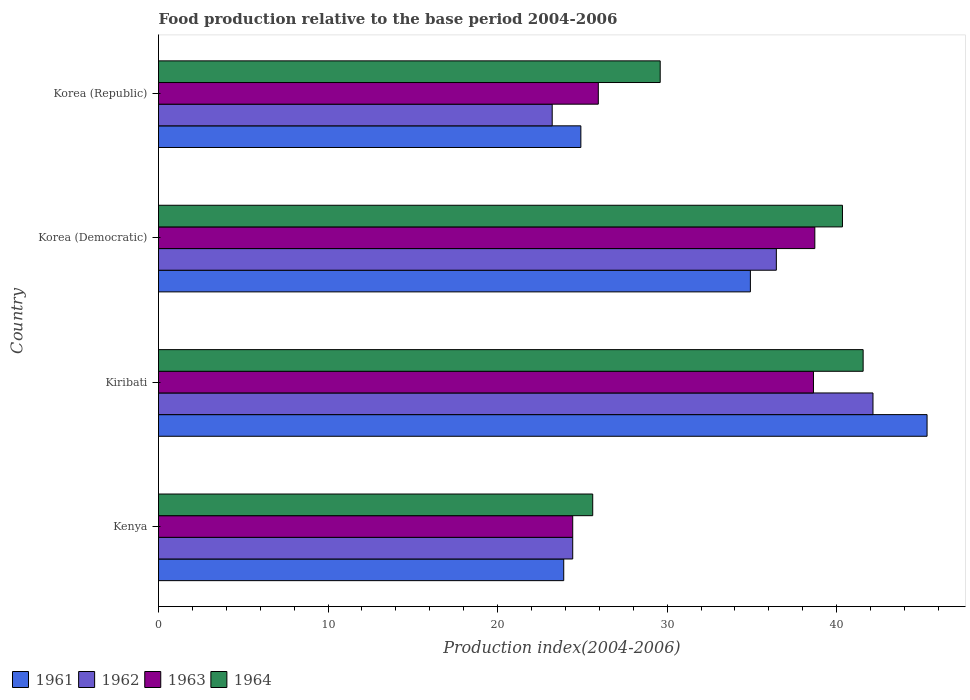How many groups of bars are there?
Make the answer very short. 4. How many bars are there on the 1st tick from the bottom?
Offer a terse response. 4. What is the label of the 4th group of bars from the top?
Provide a succinct answer. Kenya. What is the food production index in 1964 in Kiribati?
Provide a succinct answer. 41.56. Across all countries, what is the maximum food production index in 1962?
Make the answer very short. 42.14. Across all countries, what is the minimum food production index in 1964?
Make the answer very short. 25.61. In which country was the food production index in 1962 maximum?
Give a very brief answer. Kiribati. What is the total food production index in 1963 in the graph?
Give a very brief answer. 127.71. What is the difference between the food production index in 1963 in Kenya and that in Korea (Republic)?
Your answer should be compact. -1.51. What is the difference between the food production index in 1962 in Kenya and the food production index in 1963 in Kiribati?
Give a very brief answer. -14.2. What is the average food production index in 1964 per country?
Make the answer very short. 34.27. What is the difference between the food production index in 1961 and food production index in 1964 in Korea (Democratic)?
Offer a very short reply. -5.43. What is the ratio of the food production index in 1962 in Kiribati to that in Korea (Democratic)?
Ensure brevity in your answer.  1.16. Is the food production index in 1961 in Korea (Democratic) less than that in Korea (Republic)?
Offer a very short reply. No. Is the difference between the food production index in 1961 in Kenya and Korea (Republic) greater than the difference between the food production index in 1964 in Kenya and Korea (Republic)?
Make the answer very short. Yes. What is the difference between the highest and the second highest food production index in 1961?
Your response must be concise. 10.42. What is the difference between the highest and the lowest food production index in 1961?
Your answer should be compact. 21.43. Is the sum of the food production index in 1963 in Kiribati and Korea (Republic) greater than the maximum food production index in 1962 across all countries?
Make the answer very short. Yes. What does the 3rd bar from the bottom in Korea (Democratic) represents?
Provide a short and direct response. 1963. Is it the case that in every country, the sum of the food production index in 1963 and food production index in 1961 is greater than the food production index in 1964?
Your response must be concise. Yes. How many bars are there?
Make the answer very short. 16. How many countries are there in the graph?
Your answer should be compact. 4. What is the difference between two consecutive major ticks on the X-axis?
Your answer should be compact. 10. Are the values on the major ticks of X-axis written in scientific E-notation?
Your answer should be compact. No. Does the graph contain any zero values?
Offer a terse response. No. How many legend labels are there?
Your answer should be compact. 4. What is the title of the graph?
Ensure brevity in your answer.  Food production relative to the base period 2004-2006. What is the label or title of the X-axis?
Give a very brief answer. Production index(2004-2006). What is the label or title of the Y-axis?
Make the answer very short. Country. What is the Production index(2004-2006) in 1961 in Kenya?
Provide a short and direct response. 23.9. What is the Production index(2004-2006) in 1962 in Kenya?
Keep it short and to the point. 24.43. What is the Production index(2004-2006) in 1963 in Kenya?
Keep it short and to the point. 24.43. What is the Production index(2004-2006) in 1964 in Kenya?
Your response must be concise. 25.61. What is the Production index(2004-2006) of 1961 in Kiribati?
Make the answer very short. 45.33. What is the Production index(2004-2006) in 1962 in Kiribati?
Keep it short and to the point. 42.14. What is the Production index(2004-2006) in 1963 in Kiribati?
Your response must be concise. 38.63. What is the Production index(2004-2006) in 1964 in Kiribati?
Provide a short and direct response. 41.56. What is the Production index(2004-2006) in 1961 in Korea (Democratic)?
Ensure brevity in your answer.  34.91. What is the Production index(2004-2006) of 1962 in Korea (Democratic)?
Make the answer very short. 36.44. What is the Production index(2004-2006) in 1963 in Korea (Democratic)?
Keep it short and to the point. 38.71. What is the Production index(2004-2006) in 1964 in Korea (Democratic)?
Ensure brevity in your answer.  40.34. What is the Production index(2004-2006) of 1961 in Korea (Republic)?
Offer a terse response. 24.91. What is the Production index(2004-2006) in 1962 in Korea (Republic)?
Keep it short and to the point. 23.22. What is the Production index(2004-2006) of 1963 in Korea (Republic)?
Offer a very short reply. 25.94. What is the Production index(2004-2006) in 1964 in Korea (Republic)?
Ensure brevity in your answer.  29.59. Across all countries, what is the maximum Production index(2004-2006) of 1961?
Give a very brief answer. 45.33. Across all countries, what is the maximum Production index(2004-2006) of 1962?
Your response must be concise. 42.14. Across all countries, what is the maximum Production index(2004-2006) in 1963?
Ensure brevity in your answer.  38.71. Across all countries, what is the maximum Production index(2004-2006) of 1964?
Provide a succinct answer. 41.56. Across all countries, what is the minimum Production index(2004-2006) of 1961?
Offer a very short reply. 23.9. Across all countries, what is the minimum Production index(2004-2006) in 1962?
Make the answer very short. 23.22. Across all countries, what is the minimum Production index(2004-2006) of 1963?
Your answer should be compact. 24.43. Across all countries, what is the minimum Production index(2004-2006) in 1964?
Ensure brevity in your answer.  25.61. What is the total Production index(2004-2006) in 1961 in the graph?
Offer a terse response. 129.05. What is the total Production index(2004-2006) in 1962 in the graph?
Your answer should be compact. 126.23. What is the total Production index(2004-2006) of 1963 in the graph?
Provide a succinct answer. 127.71. What is the total Production index(2004-2006) of 1964 in the graph?
Make the answer very short. 137.1. What is the difference between the Production index(2004-2006) of 1961 in Kenya and that in Kiribati?
Offer a terse response. -21.43. What is the difference between the Production index(2004-2006) of 1962 in Kenya and that in Kiribati?
Offer a very short reply. -17.71. What is the difference between the Production index(2004-2006) of 1963 in Kenya and that in Kiribati?
Your answer should be compact. -14.2. What is the difference between the Production index(2004-2006) in 1964 in Kenya and that in Kiribati?
Provide a short and direct response. -15.95. What is the difference between the Production index(2004-2006) in 1961 in Kenya and that in Korea (Democratic)?
Provide a succinct answer. -11.01. What is the difference between the Production index(2004-2006) of 1962 in Kenya and that in Korea (Democratic)?
Your answer should be compact. -12.01. What is the difference between the Production index(2004-2006) in 1963 in Kenya and that in Korea (Democratic)?
Your answer should be compact. -14.28. What is the difference between the Production index(2004-2006) of 1964 in Kenya and that in Korea (Democratic)?
Make the answer very short. -14.73. What is the difference between the Production index(2004-2006) of 1961 in Kenya and that in Korea (Republic)?
Provide a succinct answer. -1.01. What is the difference between the Production index(2004-2006) of 1962 in Kenya and that in Korea (Republic)?
Offer a very short reply. 1.21. What is the difference between the Production index(2004-2006) of 1963 in Kenya and that in Korea (Republic)?
Provide a succinct answer. -1.51. What is the difference between the Production index(2004-2006) of 1964 in Kenya and that in Korea (Republic)?
Your answer should be compact. -3.98. What is the difference between the Production index(2004-2006) in 1961 in Kiribati and that in Korea (Democratic)?
Give a very brief answer. 10.42. What is the difference between the Production index(2004-2006) of 1963 in Kiribati and that in Korea (Democratic)?
Offer a very short reply. -0.08. What is the difference between the Production index(2004-2006) of 1964 in Kiribati and that in Korea (Democratic)?
Your response must be concise. 1.22. What is the difference between the Production index(2004-2006) of 1961 in Kiribati and that in Korea (Republic)?
Offer a terse response. 20.42. What is the difference between the Production index(2004-2006) in 1962 in Kiribati and that in Korea (Republic)?
Give a very brief answer. 18.92. What is the difference between the Production index(2004-2006) of 1963 in Kiribati and that in Korea (Republic)?
Ensure brevity in your answer.  12.69. What is the difference between the Production index(2004-2006) in 1964 in Kiribati and that in Korea (Republic)?
Provide a short and direct response. 11.97. What is the difference between the Production index(2004-2006) in 1961 in Korea (Democratic) and that in Korea (Republic)?
Your response must be concise. 10. What is the difference between the Production index(2004-2006) in 1962 in Korea (Democratic) and that in Korea (Republic)?
Provide a short and direct response. 13.22. What is the difference between the Production index(2004-2006) in 1963 in Korea (Democratic) and that in Korea (Republic)?
Provide a short and direct response. 12.77. What is the difference between the Production index(2004-2006) in 1964 in Korea (Democratic) and that in Korea (Republic)?
Provide a succinct answer. 10.75. What is the difference between the Production index(2004-2006) in 1961 in Kenya and the Production index(2004-2006) in 1962 in Kiribati?
Provide a succinct answer. -18.24. What is the difference between the Production index(2004-2006) of 1961 in Kenya and the Production index(2004-2006) of 1963 in Kiribati?
Provide a succinct answer. -14.73. What is the difference between the Production index(2004-2006) of 1961 in Kenya and the Production index(2004-2006) of 1964 in Kiribati?
Provide a short and direct response. -17.66. What is the difference between the Production index(2004-2006) in 1962 in Kenya and the Production index(2004-2006) in 1963 in Kiribati?
Your response must be concise. -14.2. What is the difference between the Production index(2004-2006) in 1962 in Kenya and the Production index(2004-2006) in 1964 in Kiribati?
Give a very brief answer. -17.13. What is the difference between the Production index(2004-2006) of 1963 in Kenya and the Production index(2004-2006) of 1964 in Kiribati?
Your answer should be compact. -17.13. What is the difference between the Production index(2004-2006) in 1961 in Kenya and the Production index(2004-2006) in 1962 in Korea (Democratic)?
Offer a very short reply. -12.54. What is the difference between the Production index(2004-2006) of 1961 in Kenya and the Production index(2004-2006) of 1963 in Korea (Democratic)?
Offer a terse response. -14.81. What is the difference between the Production index(2004-2006) of 1961 in Kenya and the Production index(2004-2006) of 1964 in Korea (Democratic)?
Your response must be concise. -16.44. What is the difference between the Production index(2004-2006) in 1962 in Kenya and the Production index(2004-2006) in 1963 in Korea (Democratic)?
Provide a succinct answer. -14.28. What is the difference between the Production index(2004-2006) in 1962 in Kenya and the Production index(2004-2006) in 1964 in Korea (Democratic)?
Keep it short and to the point. -15.91. What is the difference between the Production index(2004-2006) in 1963 in Kenya and the Production index(2004-2006) in 1964 in Korea (Democratic)?
Your response must be concise. -15.91. What is the difference between the Production index(2004-2006) of 1961 in Kenya and the Production index(2004-2006) of 1962 in Korea (Republic)?
Ensure brevity in your answer.  0.68. What is the difference between the Production index(2004-2006) in 1961 in Kenya and the Production index(2004-2006) in 1963 in Korea (Republic)?
Make the answer very short. -2.04. What is the difference between the Production index(2004-2006) in 1961 in Kenya and the Production index(2004-2006) in 1964 in Korea (Republic)?
Offer a terse response. -5.69. What is the difference between the Production index(2004-2006) in 1962 in Kenya and the Production index(2004-2006) in 1963 in Korea (Republic)?
Your answer should be very brief. -1.51. What is the difference between the Production index(2004-2006) of 1962 in Kenya and the Production index(2004-2006) of 1964 in Korea (Republic)?
Offer a terse response. -5.16. What is the difference between the Production index(2004-2006) of 1963 in Kenya and the Production index(2004-2006) of 1964 in Korea (Republic)?
Offer a very short reply. -5.16. What is the difference between the Production index(2004-2006) in 1961 in Kiribati and the Production index(2004-2006) in 1962 in Korea (Democratic)?
Make the answer very short. 8.89. What is the difference between the Production index(2004-2006) in 1961 in Kiribati and the Production index(2004-2006) in 1963 in Korea (Democratic)?
Provide a succinct answer. 6.62. What is the difference between the Production index(2004-2006) of 1961 in Kiribati and the Production index(2004-2006) of 1964 in Korea (Democratic)?
Provide a succinct answer. 4.99. What is the difference between the Production index(2004-2006) of 1962 in Kiribati and the Production index(2004-2006) of 1963 in Korea (Democratic)?
Give a very brief answer. 3.43. What is the difference between the Production index(2004-2006) of 1963 in Kiribati and the Production index(2004-2006) of 1964 in Korea (Democratic)?
Your answer should be very brief. -1.71. What is the difference between the Production index(2004-2006) in 1961 in Kiribati and the Production index(2004-2006) in 1962 in Korea (Republic)?
Offer a very short reply. 22.11. What is the difference between the Production index(2004-2006) in 1961 in Kiribati and the Production index(2004-2006) in 1963 in Korea (Republic)?
Provide a short and direct response. 19.39. What is the difference between the Production index(2004-2006) in 1961 in Kiribati and the Production index(2004-2006) in 1964 in Korea (Republic)?
Keep it short and to the point. 15.74. What is the difference between the Production index(2004-2006) in 1962 in Kiribati and the Production index(2004-2006) in 1963 in Korea (Republic)?
Offer a terse response. 16.2. What is the difference between the Production index(2004-2006) in 1962 in Kiribati and the Production index(2004-2006) in 1964 in Korea (Republic)?
Provide a succinct answer. 12.55. What is the difference between the Production index(2004-2006) of 1963 in Kiribati and the Production index(2004-2006) of 1964 in Korea (Republic)?
Offer a very short reply. 9.04. What is the difference between the Production index(2004-2006) of 1961 in Korea (Democratic) and the Production index(2004-2006) of 1962 in Korea (Republic)?
Give a very brief answer. 11.69. What is the difference between the Production index(2004-2006) in 1961 in Korea (Democratic) and the Production index(2004-2006) in 1963 in Korea (Republic)?
Offer a very short reply. 8.97. What is the difference between the Production index(2004-2006) in 1961 in Korea (Democratic) and the Production index(2004-2006) in 1964 in Korea (Republic)?
Your answer should be compact. 5.32. What is the difference between the Production index(2004-2006) of 1962 in Korea (Democratic) and the Production index(2004-2006) of 1963 in Korea (Republic)?
Offer a very short reply. 10.5. What is the difference between the Production index(2004-2006) in 1962 in Korea (Democratic) and the Production index(2004-2006) in 1964 in Korea (Republic)?
Provide a succinct answer. 6.85. What is the difference between the Production index(2004-2006) of 1963 in Korea (Democratic) and the Production index(2004-2006) of 1964 in Korea (Republic)?
Ensure brevity in your answer.  9.12. What is the average Production index(2004-2006) in 1961 per country?
Give a very brief answer. 32.26. What is the average Production index(2004-2006) in 1962 per country?
Your answer should be compact. 31.56. What is the average Production index(2004-2006) of 1963 per country?
Your answer should be very brief. 31.93. What is the average Production index(2004-2006) in 1964 per country?
Give a very brief answer. 34.27. What is the difference between the Production index(2004-2006) in 1961 and Production index(2004-2006) in 1962 in Kenya?
Provide a short and direct response. -0.53. What is the difference between the Production index(2004-2006) in 1961 and Production index(2004-2006) in 1963 in Kenya?
Your response must be concise. -0.53. What is the difference between the Production index(2004-2006) in 1961 and Production index(2004-2006) in 1964 in Kenya?
Make the answer very short. -1.71. What is the difference between the Production index(2004-2006) of 1962 and Production index(2004-2006) of 1964 in Kenya?
Your response must be concise. -1.18. What is the difference between the Production index(2004-2006) in 1963 and Production index(2004-2006) in 1964 in Kenya?
Your response must be concise. -1.18. What is the difference between the Production index(2004-2006) in 1961 and Production index(2004-2006) in 1962 in Kiribati?
Provide a short and direct response. 3.19. What is the difference between the Production index(2004-2006) of 1961 and Production index(2004-2006) of 1964 in Kiribati?
Offer a terse response. 3.77. What is the difference between the Production index(2004-2006) in 1962 and Production index(2004-2006) in 1963 in Kiribati?
Keep it short and to the point. 3.51. What is the difference between the Production index(2004-2006) in 1962 and Production index(2004-2006) in 1964 in Kiribati?
Make the answer very short. 0.58. What is the difference between the Production index(2004-2006) in 1963 and Production index(2004-2006) in 1964 in Kiribati?
Give a very brief answer. -2.93. What is the difference between the Production index(2004-2006) in 1961 and Production index(2004-2006) in 1962 in Korea (Democratic)?
Your answer should be compact. -1.53. What is the difference between the Production index(2004-2006) in 1961 and Production index(2004-2006) in 1963 in Korea (Democratic)?
Give a very brief answer. -3.8. What is the difference between the Production index(2004-2006) in 1961 and Production index(2004-2006) in 1964 in Korea (Democratic)?
Provide a succinct answer. -5.43. What is the difference between the Production index(2004-2006) of 1962 and Production index(2004-2006) of 1963 in Korea (Democratic)?
Provide a short and direct response. -2.27. What is the difference between the Production index(2004-2006) of 1963 and Production index(2004-2006) of 1964 in Korea (Democratic)?
Make the answer very short. -1.63. What is the difference between the Production index(2004-2006) in 1961 and Production index(2004-2006) in 1962 in Korea (Republic)?
Ensure brevity in your answer.  1.69. What is the difference between the Production index(2004-2006) of 1961 and Production index(2004-2006) of 1963 in Korea (Republic)?
Offer a terse response. -1.03. What is the difference between the Production index(2004-2006) of 1961 and Production index(2004-2006) of 1964 in Korea (Republic)?
Keep it short and to the point. -4.68. What is the difference between the Production index(2004-2006) of 1962 and Production index(2004-2006) of 1963 in Korea (Republic)?
Your answer should be very brief. -2.72. What is the difference between the Production index(2004-2006) of 1962 and Production index(2004-2006) of 1964 in Korea (Republic)?
Offer a very short reply. -6.37. What is the difference between the Production index(2004-2006) in 1963 and Production index(2004-2006) in 1964 in Korea (Republic)?
Your answer should be compact. -3.65. What is the ratio of the Production index(2004-2006) in 1961 in Kenya to that in Kiribati?
Your response must be concise. 0.53. What is the ratio of the Production index(2004-2006) in 1962 in Kenya to that in Kiribati?
Offer a terse response. 0.58. What is the ratio of the Production index(2004-2006) of 1963 in Kenya to that in Kiribati?
Keep it short and to the point. 0.63. What is the ratio of the Production index(2004-2006) in 1964 in Kenya to that in Kiribati?
Your answer should be very brief. 0.62. What is the ratio of the Production index(2004-2006) in 1961 in Kenya to that in Korea (Democratic)?
Give a very brief answer. 0.68. What is the ratio of the Production index(2004-2006) in 1962 in Kenya to that in Korea (Democratic)?
Your answer should be very brief. 0.67. What is the ratio of the Production index(2004-2006) of 1963 in Kenya to that in Korea (Democratic)?
Provide a short and direct response. 0.63. What is the ratio of the Production index(2004-2006) of 1964 in Kenya to that in Korea (Democratic)?
Make the answer very short. 0.63. What is the ratio of the Production index(2004-2006) in 1961 in Kenya to that in Korea (Republic)?
Your response must be concise. 0.96. What is the ratio of the Production index(2004-2006) in 1962 in Kenya to that in Korea (Republic)?
Your answer should be compact. 1.05. What is the ratio of the Production index(2004-2006) of 1963 in Kenya to that in Korea (Republic)?
Your answer should be very brief. 0.94. What is the ratio of the Production index(2004-2006) of 1964 in Kenya to that in Korea (Republic)?
Ensure brevity in your answer.  0.87. What is the ratio of the Production index(2004-2006) in 1961 in Kiribati to that in Korea (Democratic)?
Offer a very short reply. 1.3. What is the ratio of the Production index(2004-2006) in 1962 in Kiribati to that in Korea (Democratic)?
Keep it short and to the point. 1.16. What is the ratio of the Production index(2004-2006) in 1963 in Kiribati to that in Korea (Democratic)?
Provide a short and direct response. 1. What is the ratio of the Production index(2004-2006) of 1964 in Kiribati to that in Korea (Democratic)?
Give a very brief answer. 1.03. What is the ratio of the Production index(2004-2006) of 1961 in Kiribati to that in Korea (Republic)?
Your response must be concise. 1.82. What is the ratio of the Production index(2004-2006) of 1962 in Kiribati to that in Korea (Republic)?
Offer a very short reply. 1.81. What is the ratio of the Production index(2004-2006) of 1963 in Kiribati to that in Korea (Republic)?
Ensure brevity in your answer.  1.49. What is the ratio of the Production index(2004-2006) in 1964 in Kiribati to that in Korea (Republic)?
Offer a very short reply. 1.4. What is the ratio of the Production index(2004-2006) of 1961 in Korea (Democratic) to that in Korea (Republic)?
Provide a short and direct response. 1.4. What is the ratio of the Production index(2004-2006) in 1962 in Korea (Democratic) to that in Korea (Republic)?
Provide a succinct answer. 1.57. What is the ratio of the Production index(2004-2006) in 1963 in Korea (Democratic) to that in Korea (Republic)?
Offer a very short reply. 1.49. What is the ratio of the Production index(2004-2006) of 1964 in Korea (Democratic) to that in Korea (Republic)?
Provide a short and direct response. 1.36. What is the difference between the highest and the second highest Production index(2004-2006) in 1961?
Your answer should be very brief. 10.42. What is the difference between the highest and the second highest Production index(2004-2006) in 1963?
Ensure brevity in your answer.  0.08. What is the difference between the highest and the second highest Production index(2004-2006) of 1964?
Offer a terse response. 1.22. What is the difference between the highest and the lowest Production index(2004-2006) in 1961?
Keep it short and to the point. 21.43. What is the difference between the highest and the lowest Production index(2004-2006) of 1962?
Keep it short and to the point. 18.92. What is the difference between the highest and the lowest Production index(2004-2006) of 1963?
Make the answer very short. 14.28. What is the difference between the highest and the lowest Production index(2004-2006) of 1964?
Offer a very short reply. 15.95. 